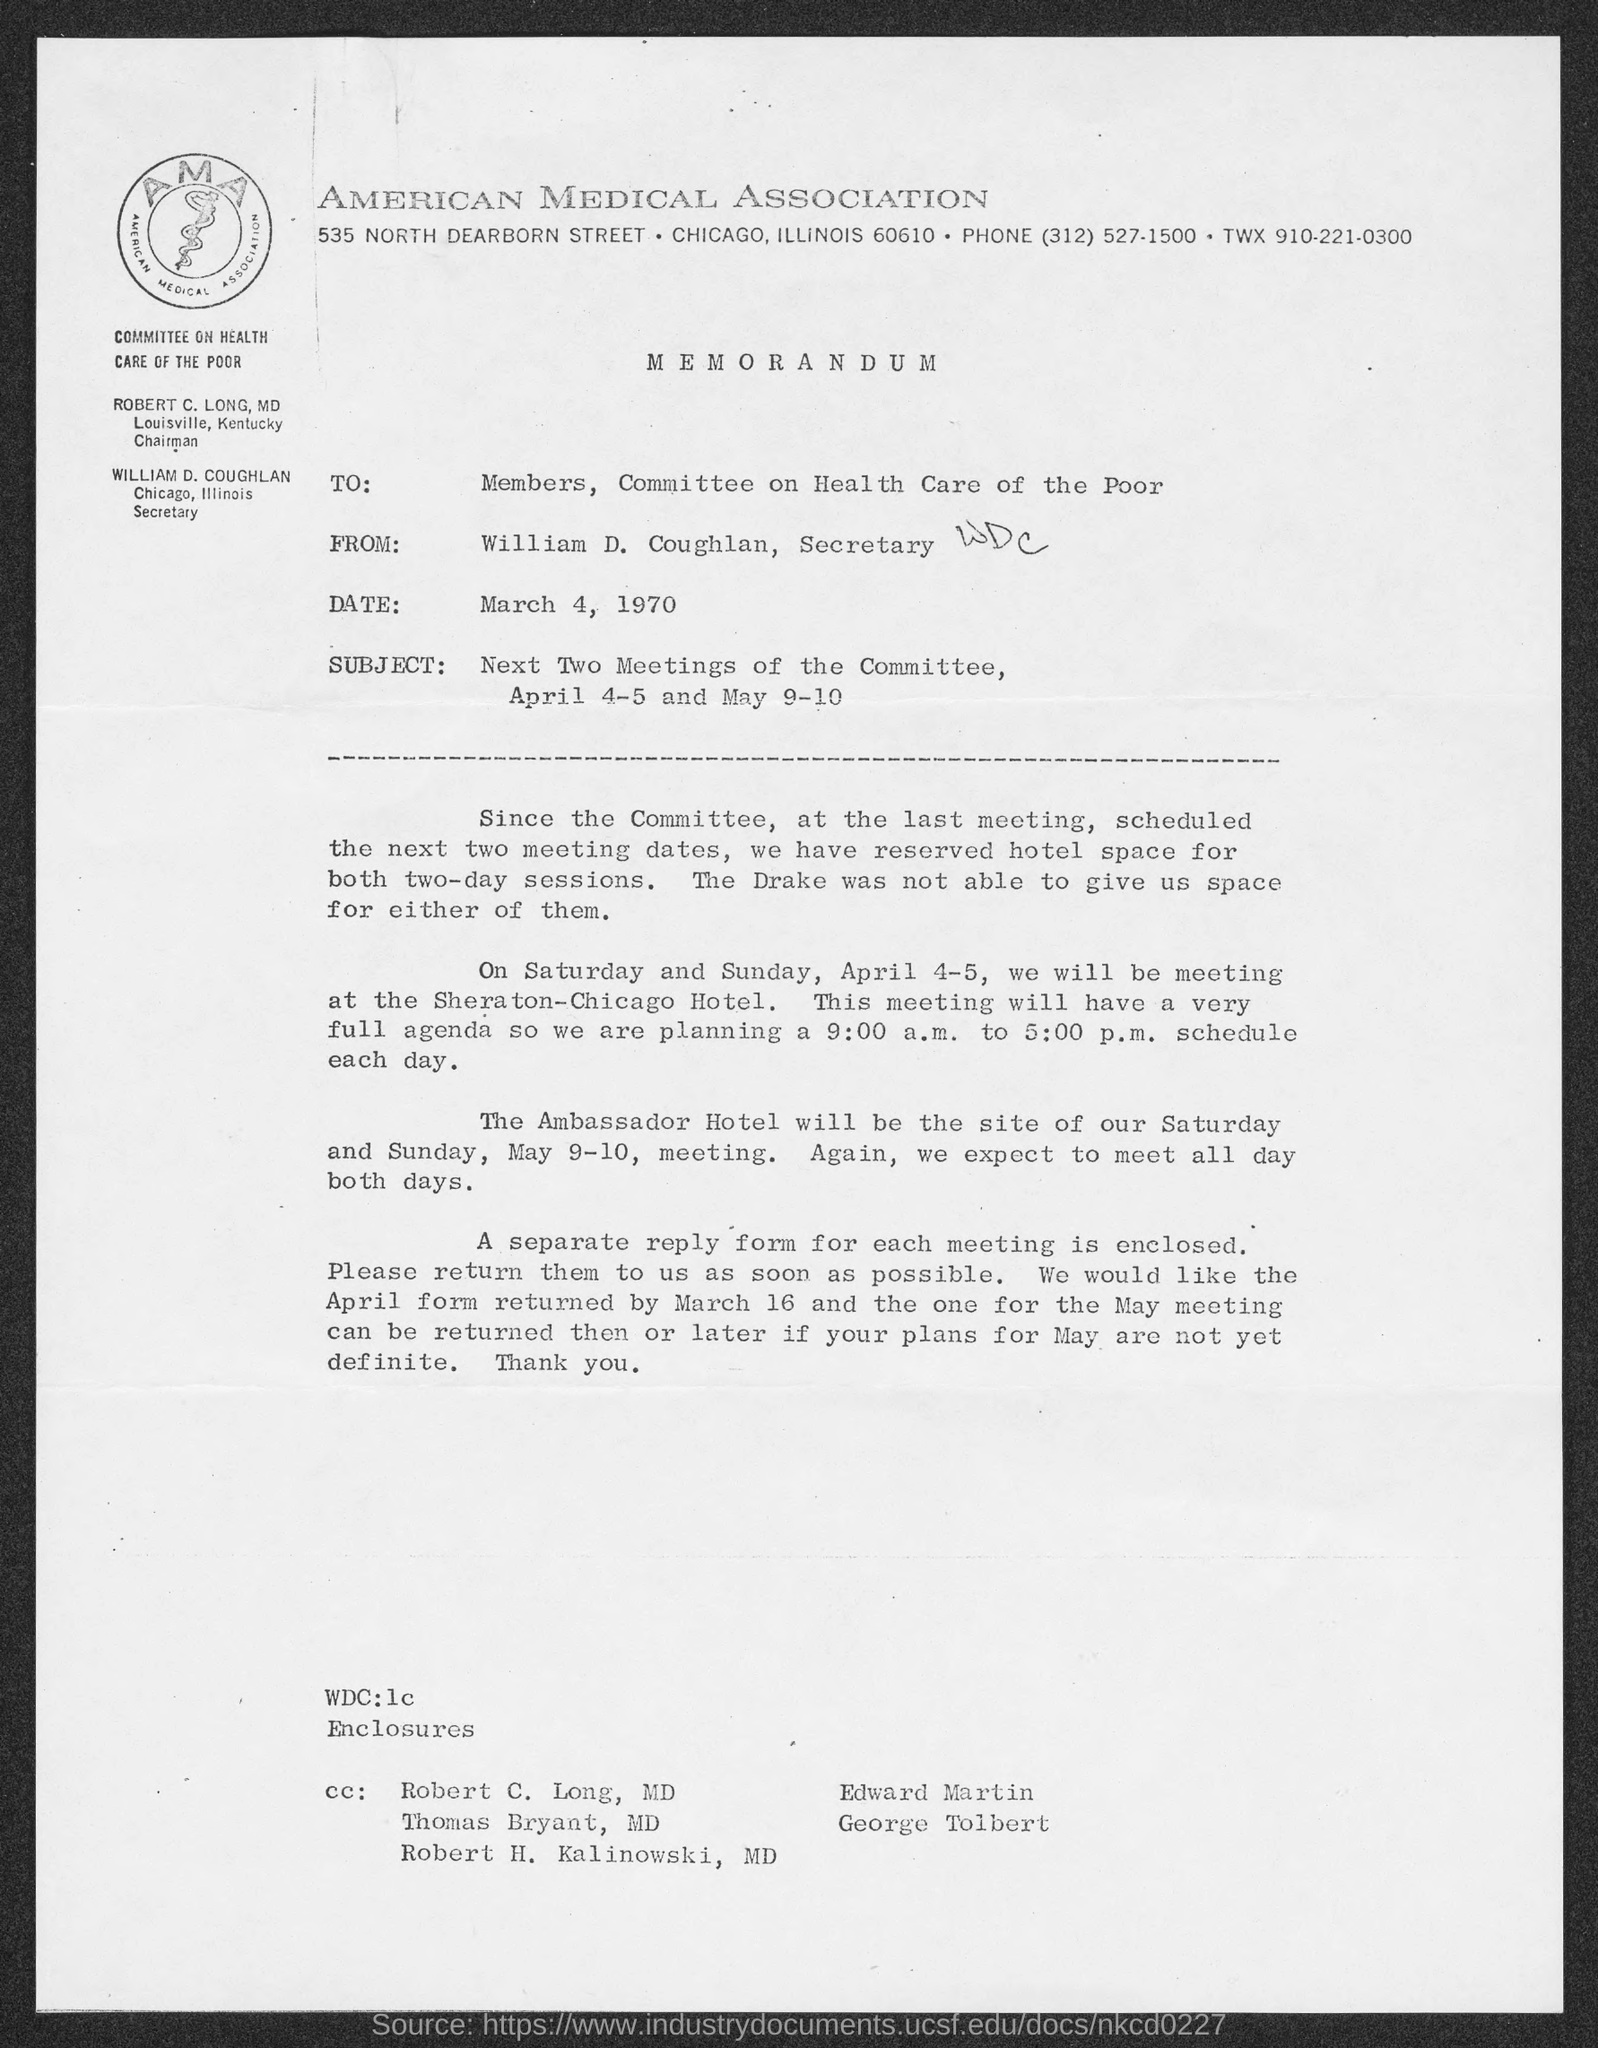List a handful of essential elements in this visual. The from address in a memorandum is William D. Coughlan. The memorandum is dated March 4, 1970. The phone number of the American Medical Association is (312) 527-1500. William D. Coughlan is the Secretary. The American Medical Association is located in Chicago. 